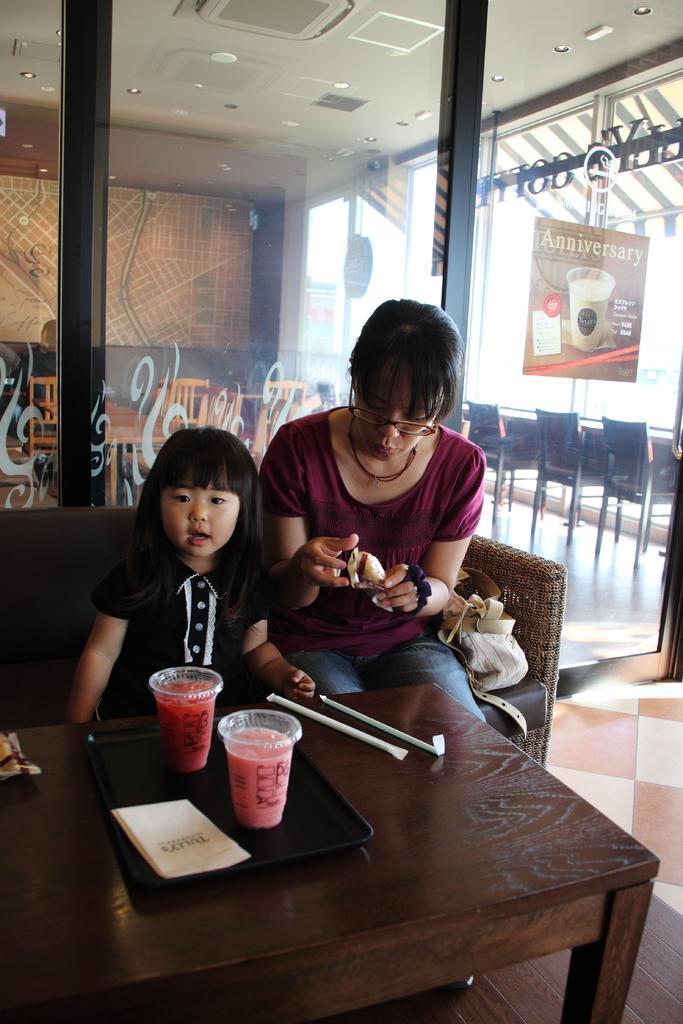Please provide a concise description of this image. In the image we can see there are two people who are sitting on sofa in front of them there is a table on which in a tray there are two juice glasses beside it there are two straws and at the back on the door it is written "Anniversary". 